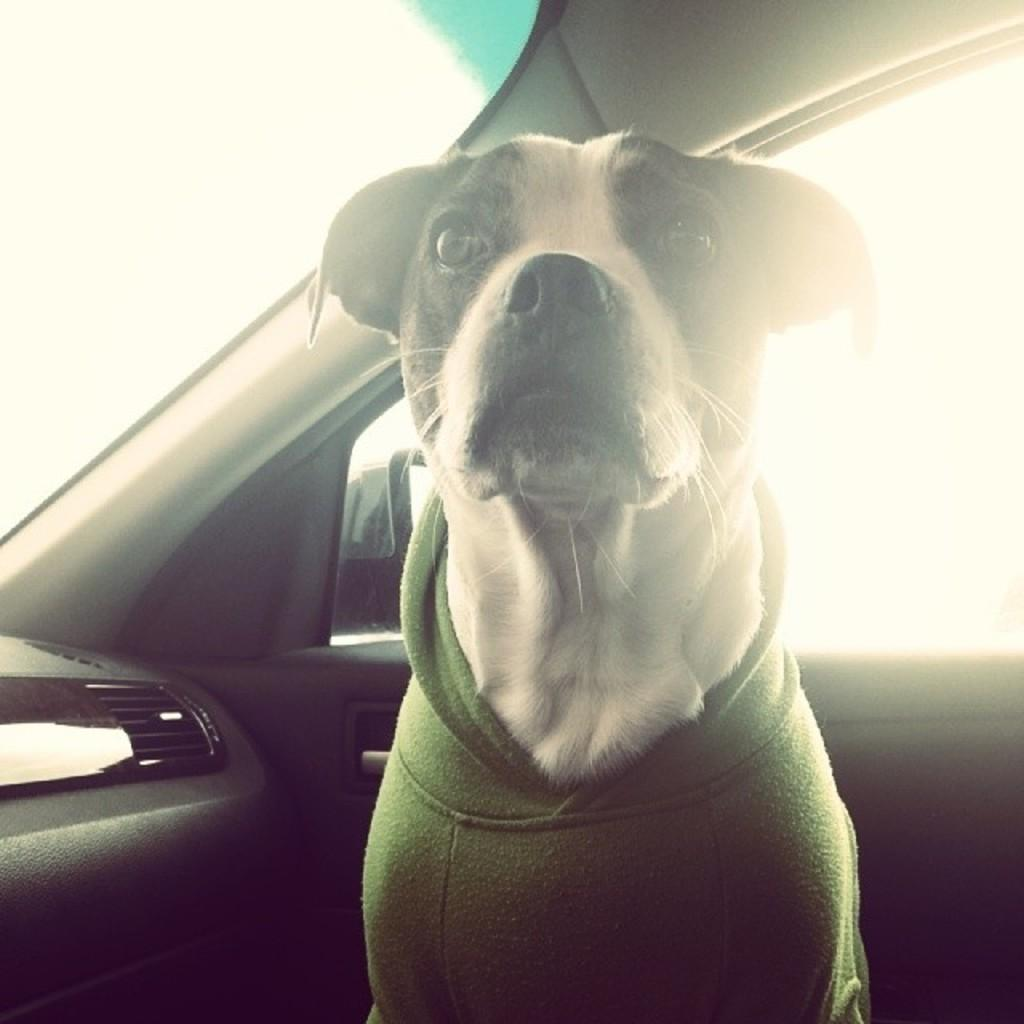What animal can be seen in the image? There is a dog in the image. Where is the dog located in the image? The dog is sitting in a vehicle. What is the dog wearing in the image? The dog is wearing clothes in the image. What can be seen in the background of the image? There is a window visible in the background of the image. What type of throat lozenges can be seen in the image? There are no throat lozenges present in the image. Can you describe the sink in the image? There is no sink present in the image. 